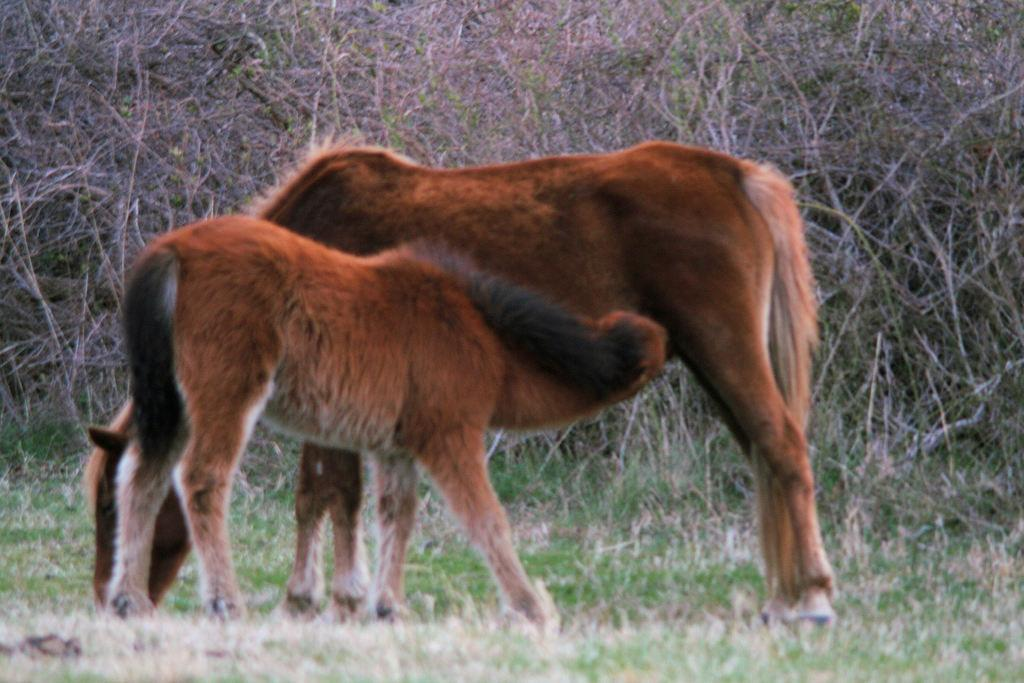How many horses are in the image? There are two horses in the image. What else can be seen in the image besides the horses? There are plants and grass in the image. Who is the creator of the basket in the image? There is no basket present in the image. 